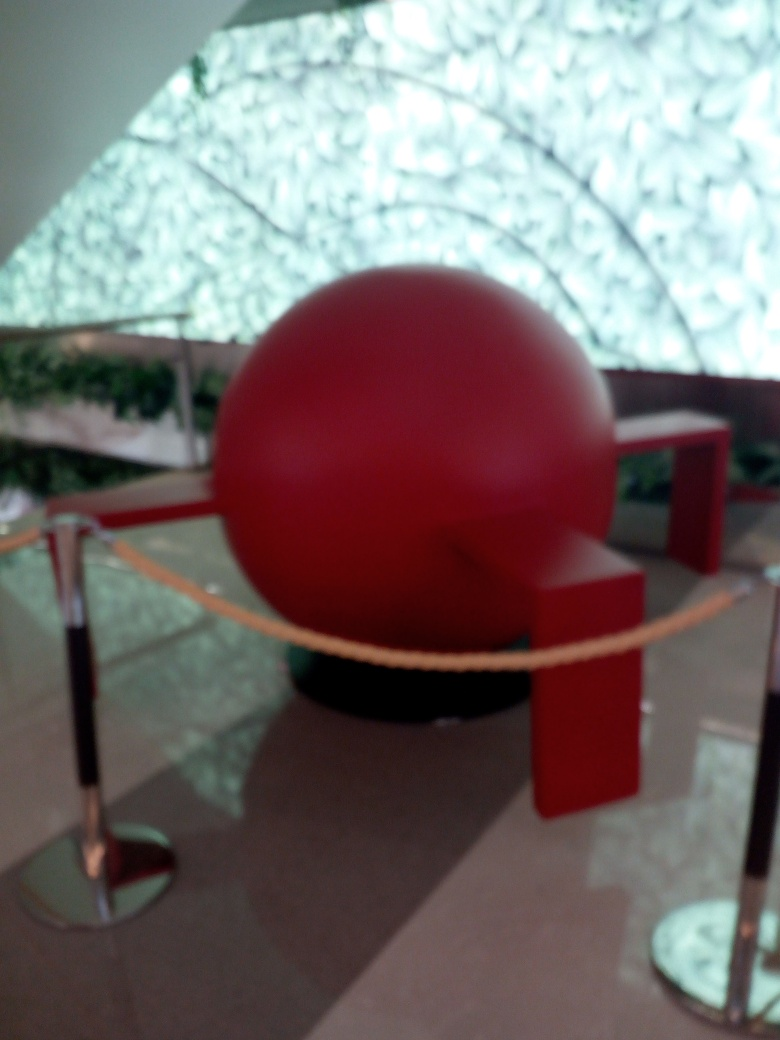What is the large red object in the center? The large red object appears to be a spherical art installation. Its smooth surface and central placement suggest it's meant to be a focal point for viewers. 